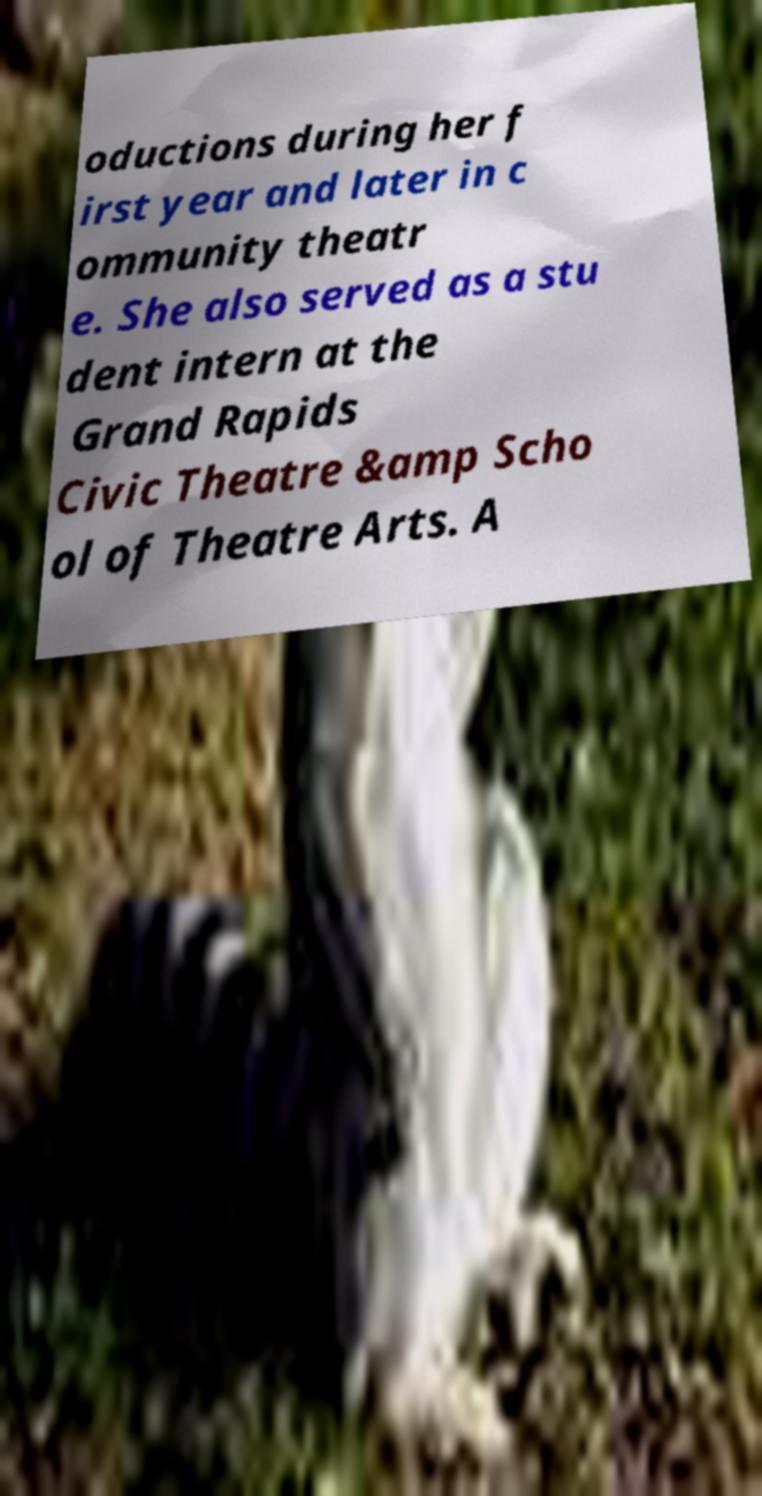Please identify and transcribe the text found in this image. oductions during her f irst year and later in c ommunity theatr e. She also served as a stu dent intern at the Grand Rapids Civic Theatre &amp Scho ol of Theatre Arts. A 